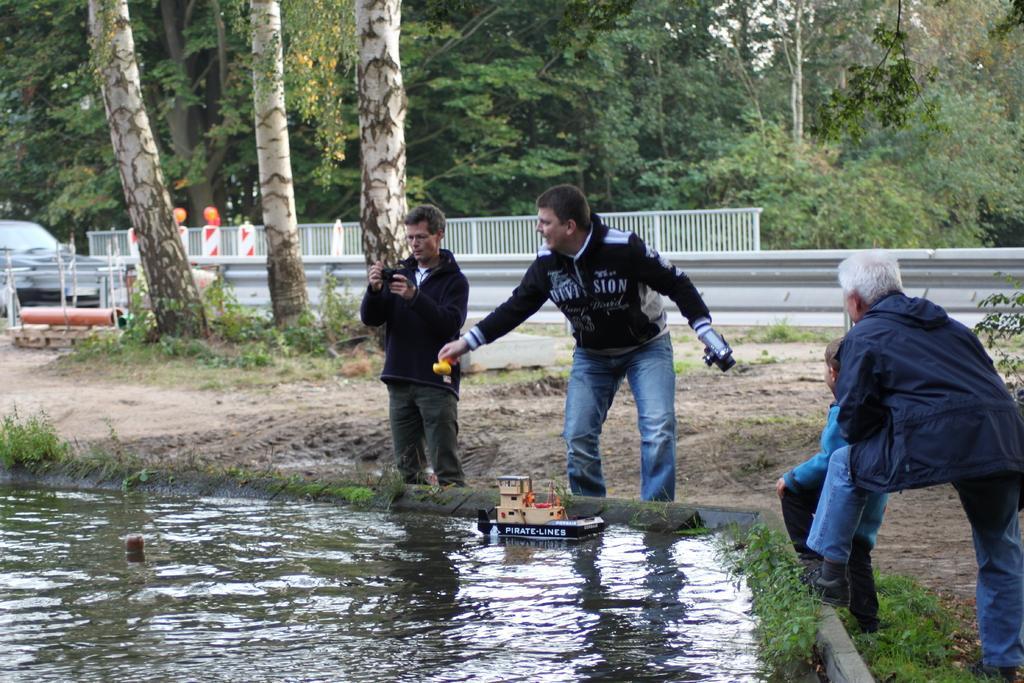Describe this image in one or two sentences. In this image we can see some persons, grass, toys and other objects. In the background of the image there is a vehicle, fence, trees and other objects. At the bottom of the image there is water. 